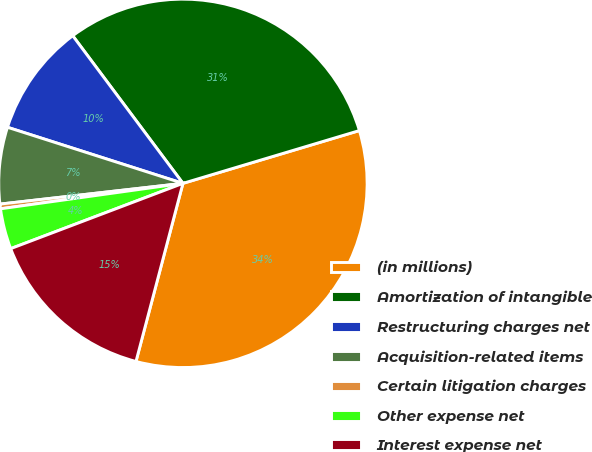Convert chart to OTSL. <chart><loc_0><loc_0><loc_500><loc_500><pie_chart><fcel>(in millions)<fcel>Amortization of intangible<fcel>Restructuring charges net<fcel>Acquisition-related items<fcel>Certain litigation charges<fcel>Other expense net<fcel>Interest expense net<nl><fcel>33.73%<fcel>30.58%<fcel>9.87%<fcel>6.72%<fcel>0.41%<fcel>3.56%<fcel>15.13%<nl></chart> 